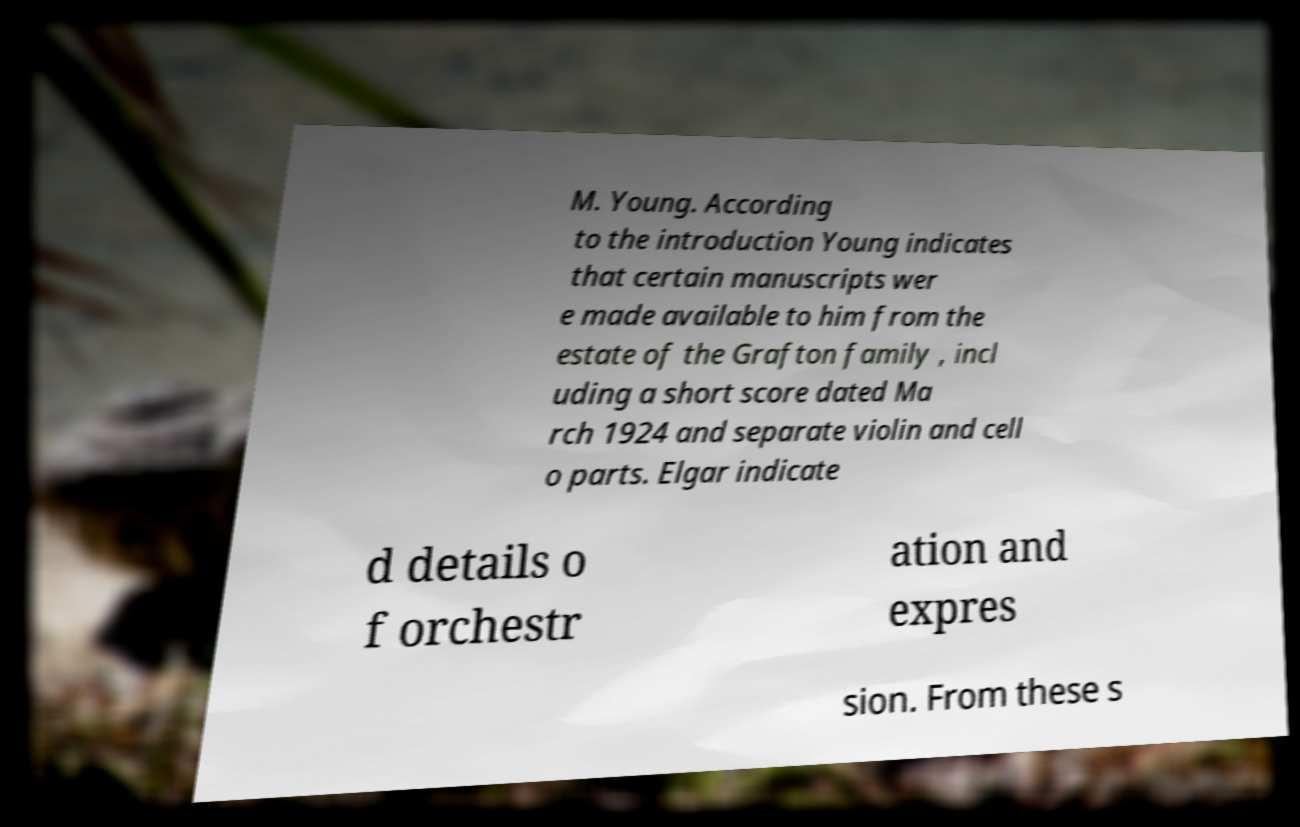Could you extract and type out the text from this image? M. Young. According to the introduction Young indicates that certain manuscripts wer e made available to him from the estate of the Grafton family , incl uding a short score dated Ma rch 1924 and separate violin and cell o parts. Elgar indicate d details o f orchestr ation and expres sion. From these s 